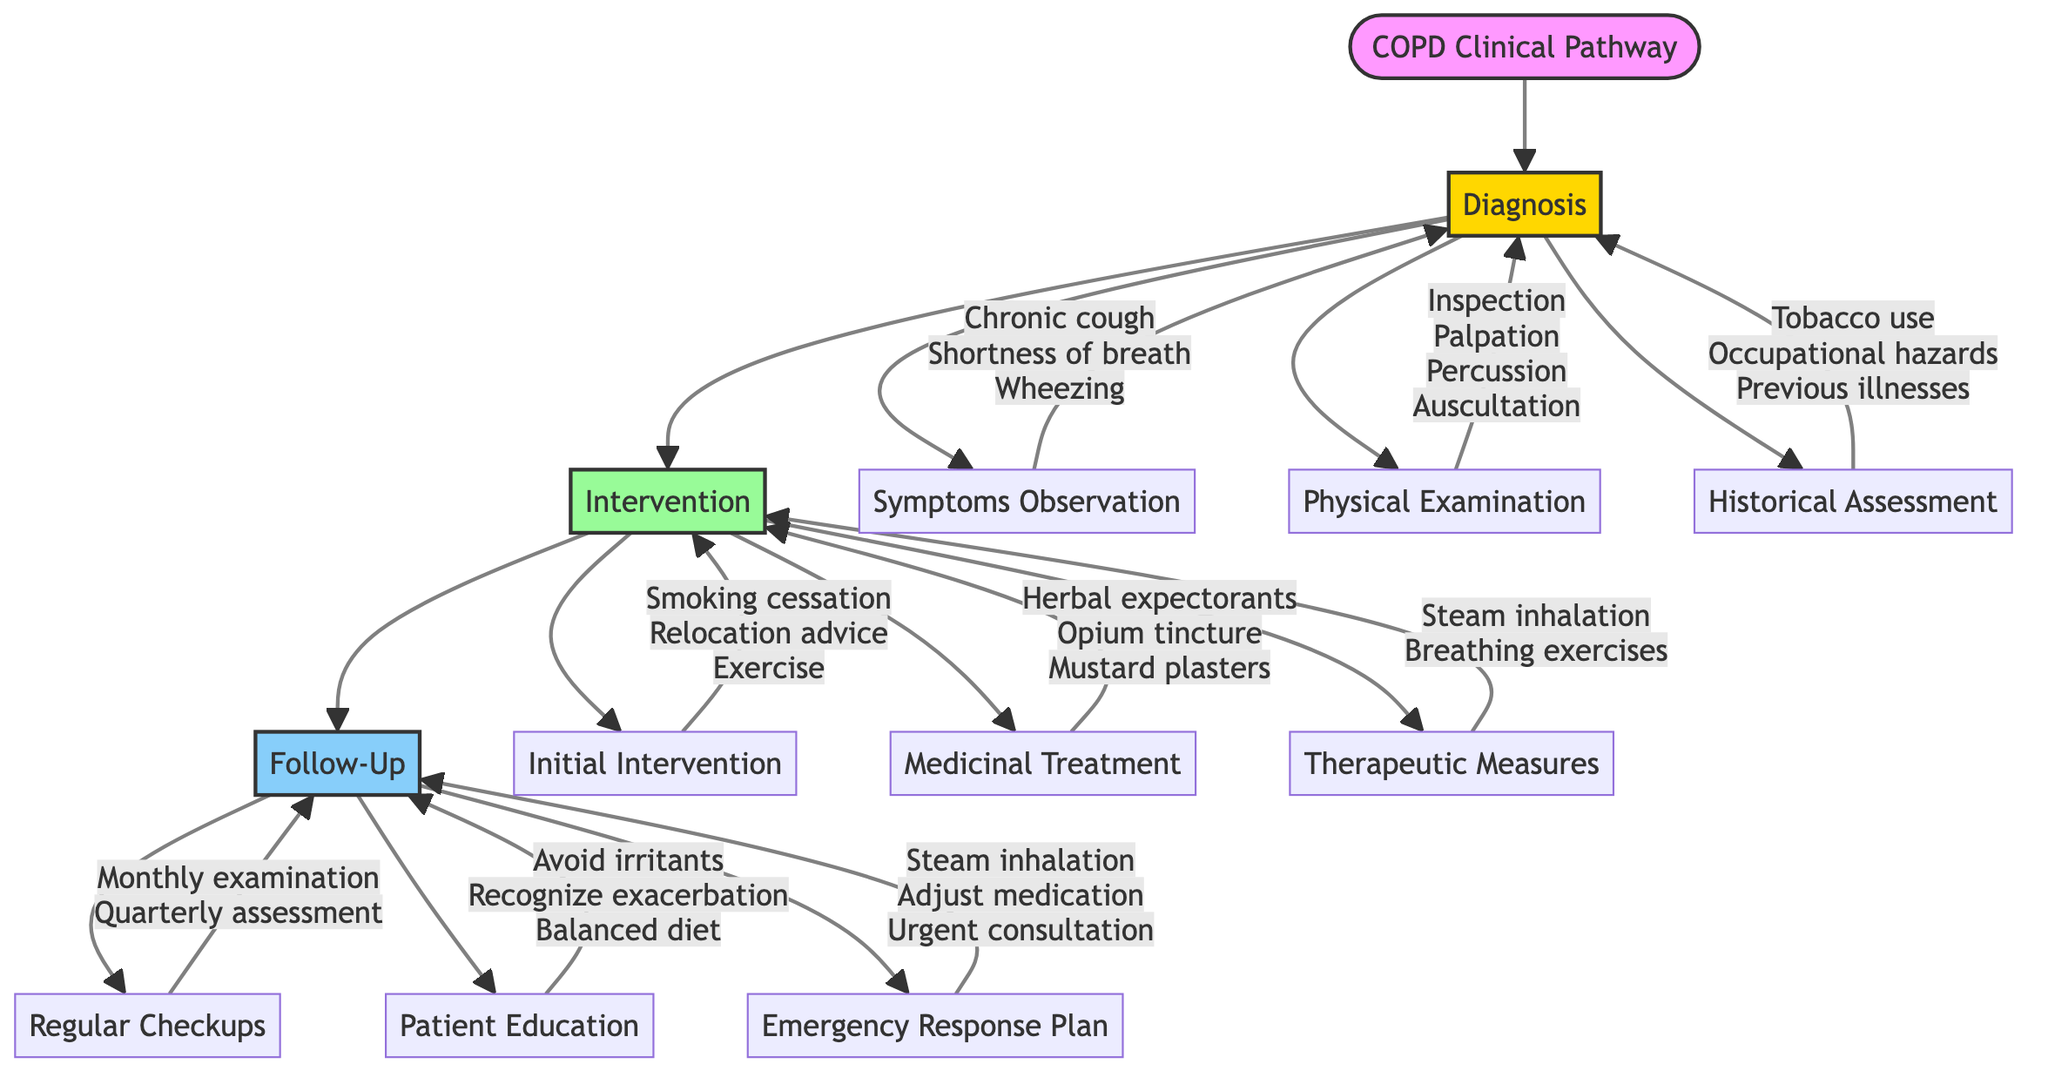What are the three symptoms observed for COPD? The diagram lists "Chronic cough," "Shortness of breath," and "Wheezing" under the "Symptoms Observation" section of the Diagnosis node.
Answer: Chronic cough, Shortness of breath, Wheezing How many types of interventions are there in the pathway? The diagram shows three distinct types of interventions: "Initial Intervention," "Medicinal Treatment," and "Therapeutic Measures." Thus, there are three types of interventions.
Answer: 3 What is included in the physical examination for COPD diagnosis? The diagram specifies four aspects included in the physical examination: "Inspection of chest," "Palpation for tenderness," "Percussion for lung density," and "Auscultation for breath sounds."
Answer: Inspection of chest, Palpation for tenderness, Percussion for lung density, Auscultation for breath sounds What measure is recommended for emergency response in case of COPD exacerbation? The diagram indicates "Immediate steam inhalation" as a measure included in the Emergency Response Plan section of Patient Follow-Ups.
Answer: Immediate steam inhalation Which intervention aims to encourage physical activity? Under "Initial Intervention," the diagram states "Encourage moderate physical exercise," which directly aims to promote physical activity for COPD patients.
Answer: Encourage moderate physical exercise What type of treatment is an opium tincture categorized under? The diagram places "Opium tincture for severe breathlessness" under the "Medicinal Treatment" section of the Intervention node, categorizing it as medicines used in treatment.
Answer: Medicinal Treatment How often should patients have regular checkups? According to the diagram, patients are recommended to have "Monthly chest examination" under the "Regular Checkups" section, indicating a frequency of once a month.
Answer: Monthly chest examination What should patients avoid as part of their education? The diagram advises patients to "Avoid respiratory irritants" as part of their education in the Patient Education section under Follow-Ups.
Answer: Avoid respiratory irritants 